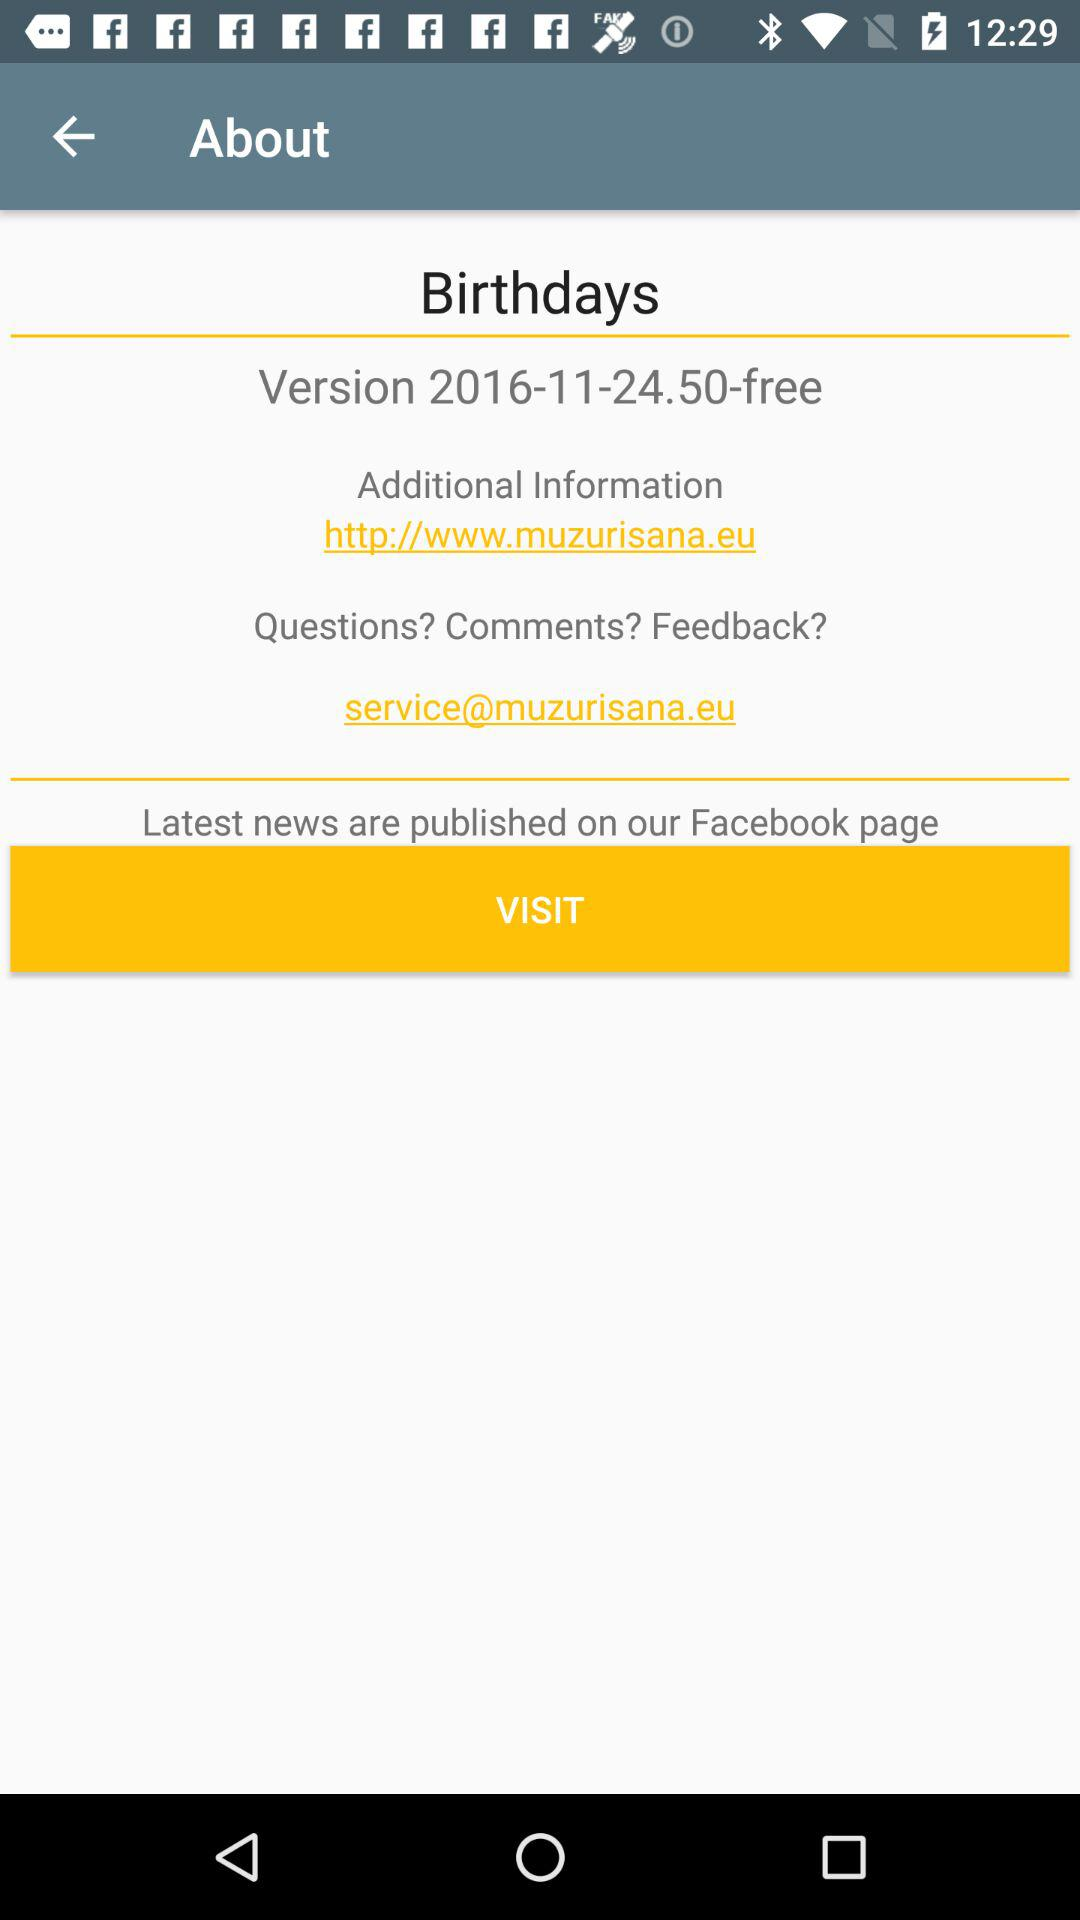What is the free version? The free version is 2016-11-24.50. 